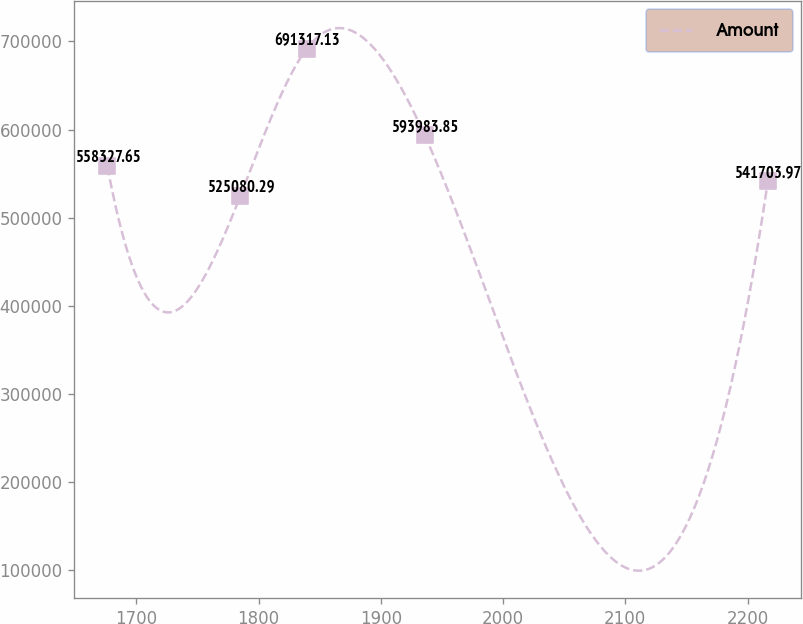Convert chart. <chart><loc_0><loc_0><loc_500><loc_500><line_chart><ecel><fcel>Amount<nl><fcel>1676.29<fcel>558328<nl><fcel>1785.19<fcel>525080<nl><fcel>1839.22<fcel>691317<nl><fcel>1935.74<fcel>593984<nl><fcel>2216.59<fcel>541704<nl></chart> 